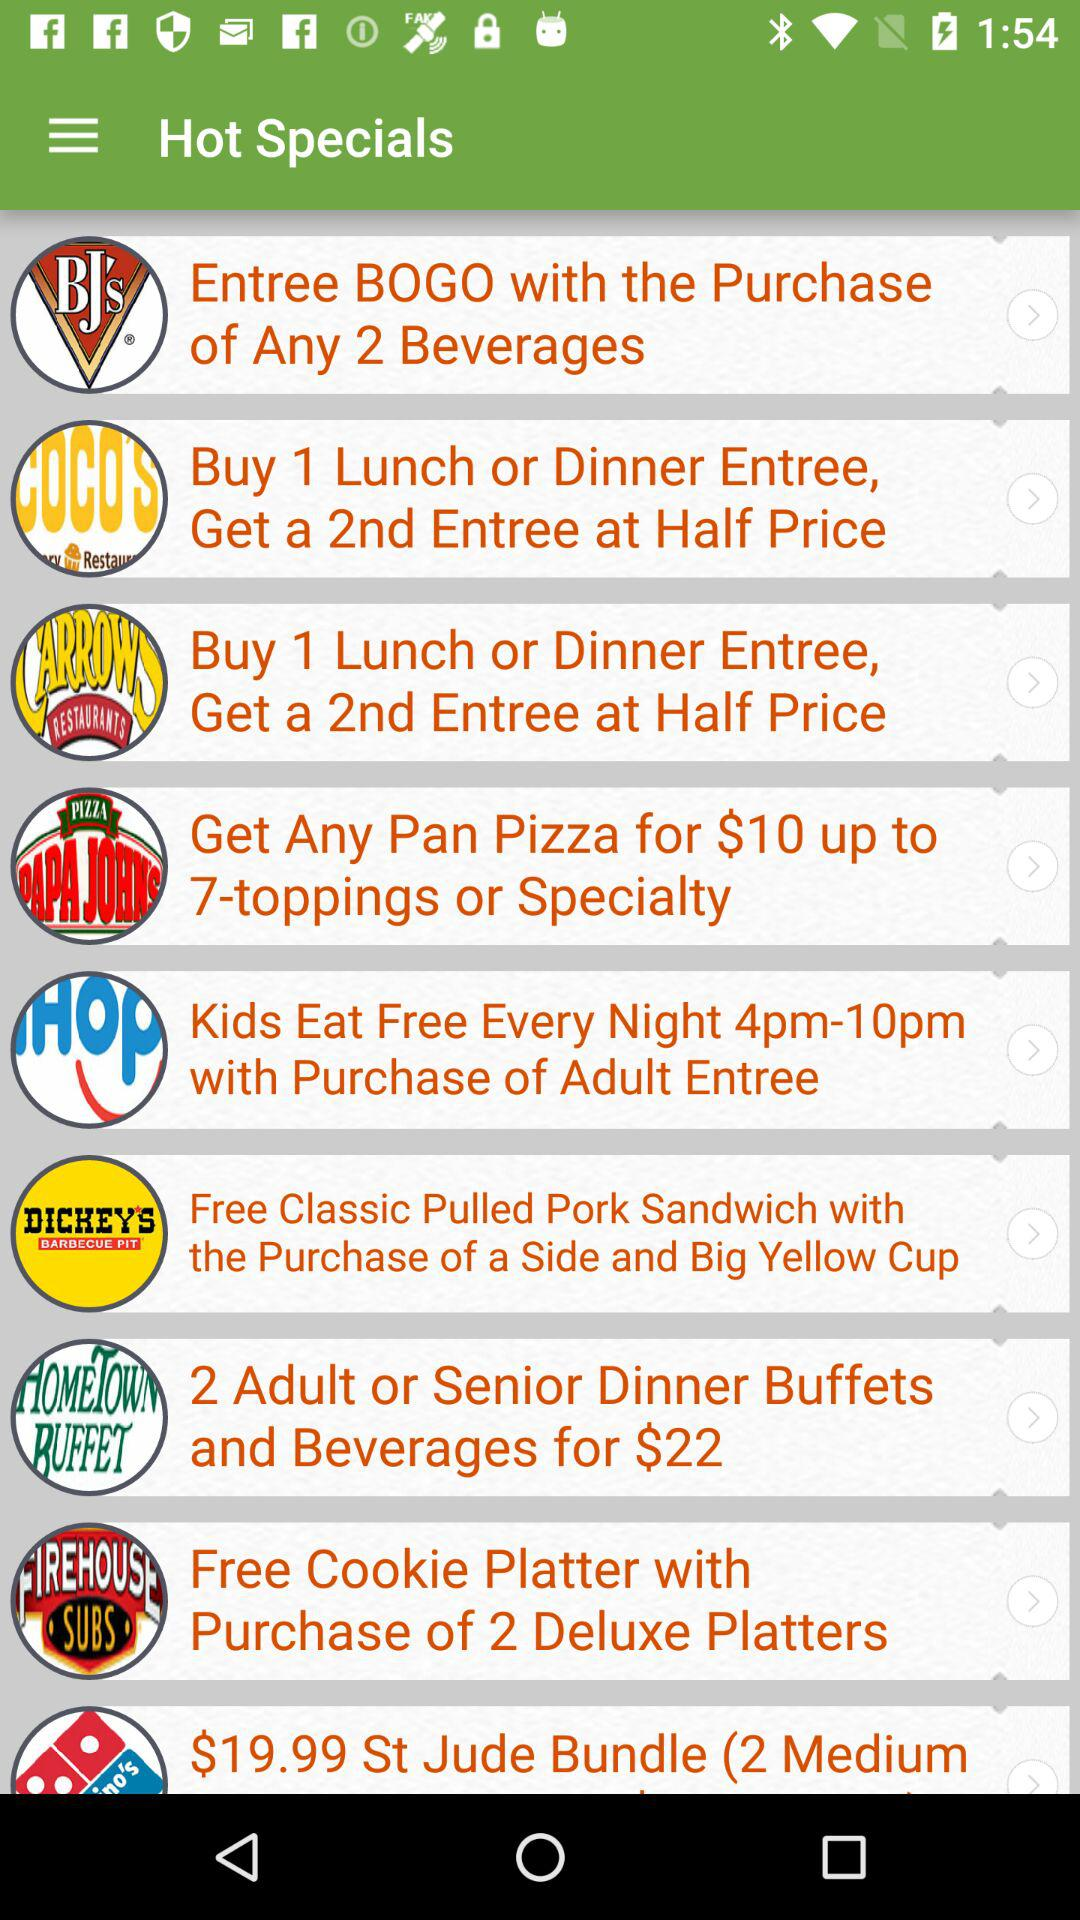What is the price of "2 Adult or Senior Dinner Buffets"? The price is $22. 